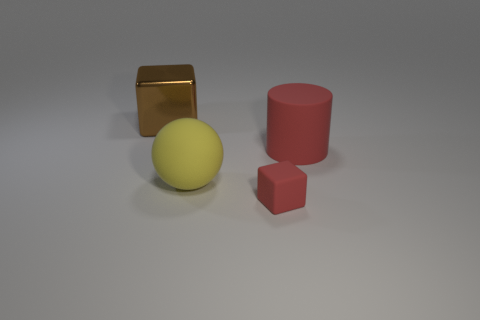Add 1 red cubes. How many objects exist? 5 Subtract all spheres. How many objects are left? 3 Add 3 tiny brown balls. How many tiny brown balls exist? 3 Subtract 1 red blocks. How many objects are left? 3 Subtract all yellow matte spheres. Subtract all red metal objects. How many objects are left? 3 Add 1 big rubber cylinders. How many big rubber cylinders are left? 2 